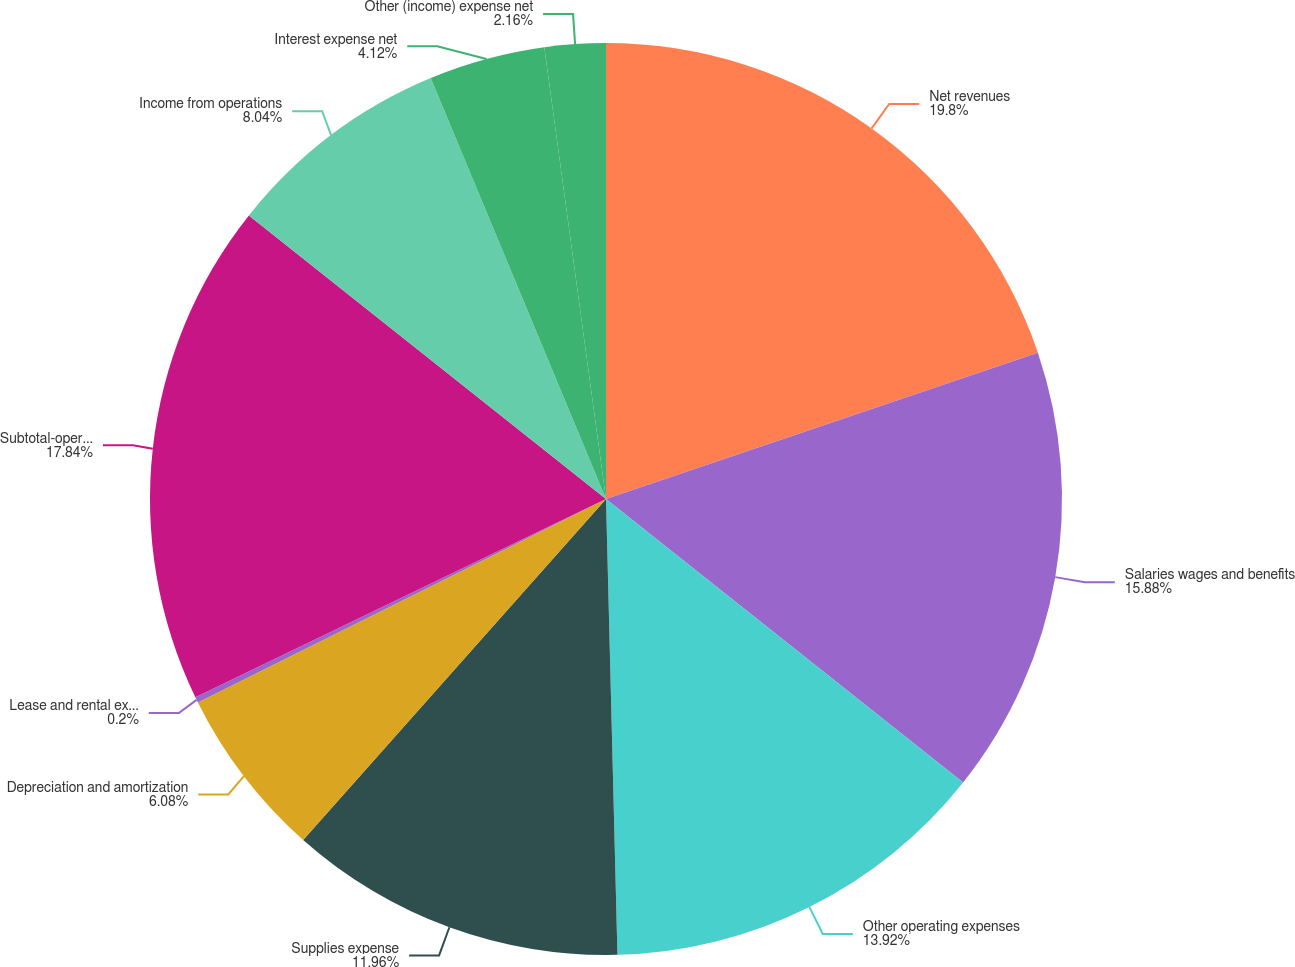Convert chart. <chart><loc_0><loc_0><loc_500><loc_500><pie_chart><fcel>Net revenues<fcel>Salaries wages and benefits<fcel>Other operating expenses<fcel>Supplies expense<fcel>Depreciation and amortization<fcel>Lease and rental expense<fcel>Subtotal-operating expenses<fcel>Income from operations<fcel>Interest expense net<fcel>Other (income) expense net<nl><fcel>19.8%<fcel>15.88%<fcel>13.92%<fcel>11.96%<fcel>6.08%<fcel>0.2%<fcel>17.84%<fcel>8.04%<fcel>4.12%<fcel>2.16%<nl></chart> 